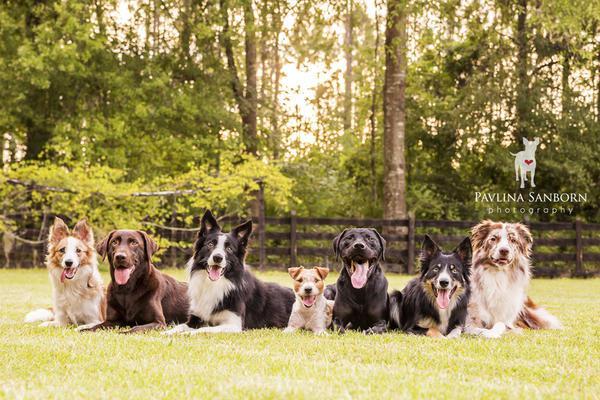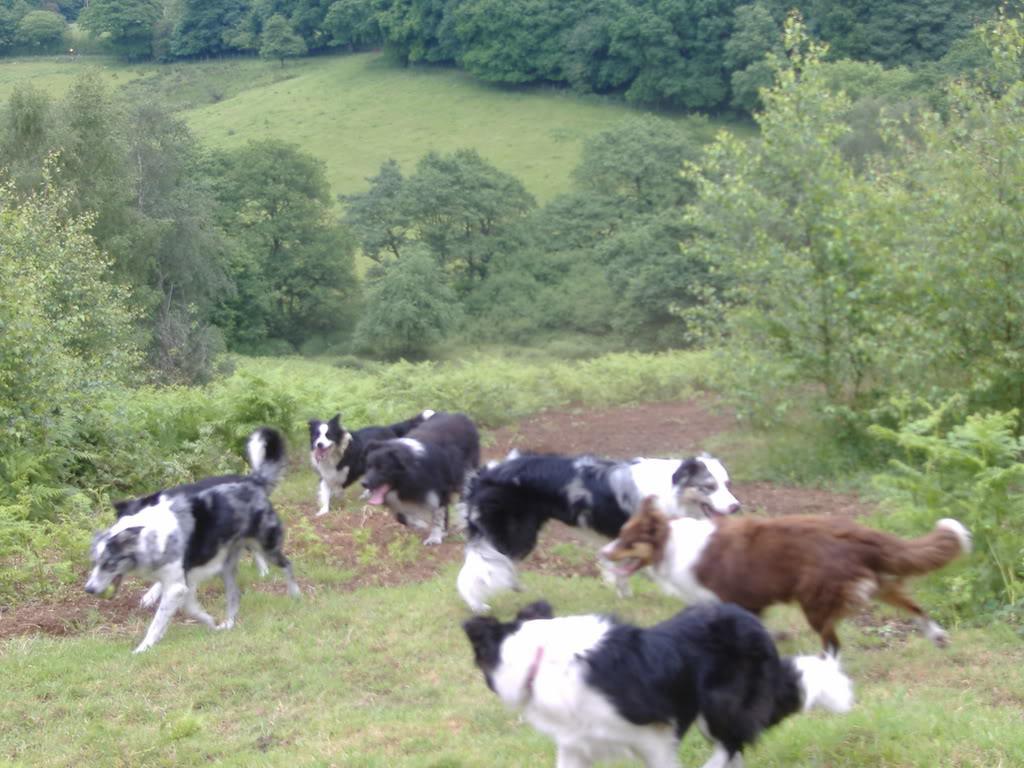The first image is the image on the left, the second image is the image on the right. Considering the images on both sides, is "There are at least three dogs with white fur elevated above another row of dogs who are sitting or laying down." valid? Answer yes or no. No. The first image is the image on the left, the second image is the image on the right. Examine the images to the left and right. Is the description "There is a brown hound dog in the image on the left." accurate? Answer yes or no. Yes. 